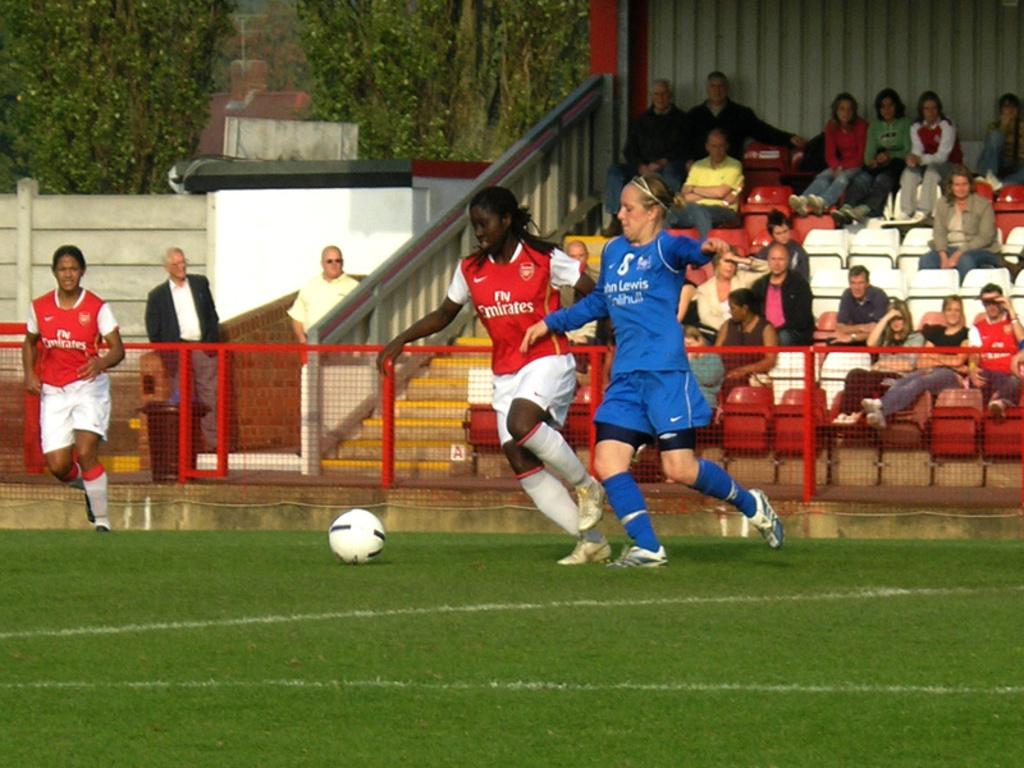<image>
Present a compact description of the photo's key features. A women soccer player wearing fly emirates jersey is in a game with another team. 